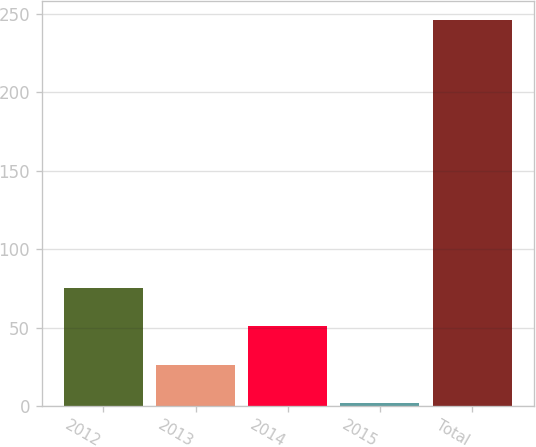Convert chart to OTSL. <chart><loc_0><loc_0><loc_500><loc_500><bar_chart><fcel>2012<fcel>2013<fcel>2014<fcel>2015<fcel>Total<nl><fcel>75.2<fcel>26.4<fcel>50.8<fcel>2<fcel>246<nl></chart> 